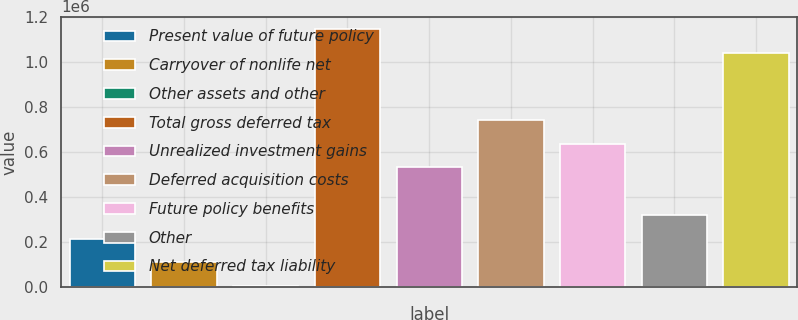<chart> <loc_0><loc_0><loc_500><loc_500><bar_chart><fcel>Present value of future policy<fcel>Carryover of nonlife net<fcel>Other assets and other<fcel>Total gross deferred tax<fcel>Unrealized investment gains<fcel>Deferred acquisition costs<fcel>Future policy benefits<fcel>Other<fcel>Net deferred tax liability<nl><fcel>216801<fcel>111293<fcel>5785<fcel>1.14609e+06<fcel>533326<fcel>744342<fcel>638834<fcel>322309<fcel>1.04058e+06<nl></chart> 